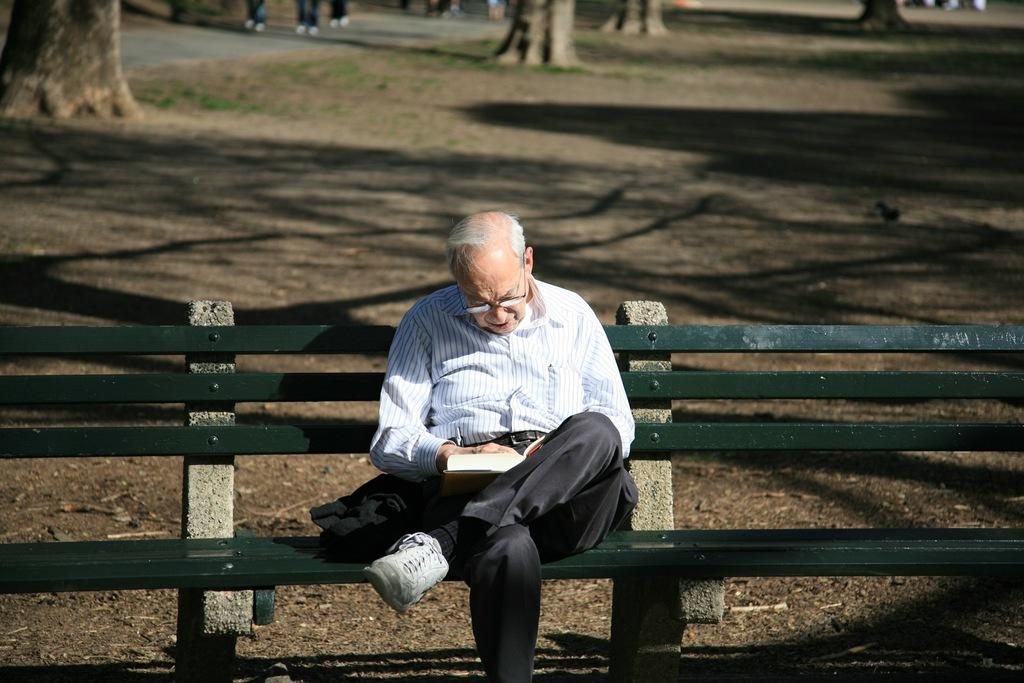Who is the main subject in the image? There is an old man in the image. What is the old man doing in the image? The old man is sitting on a bench. What accessory is the old man wearing in the image? The old man is wearing spectacles. What can be seen in the background of the image? There are trees in the background of the image. What type of scent can be detected from the flowers in the image? There are no flowers present in the image, so it is not possible to detect any scent. 